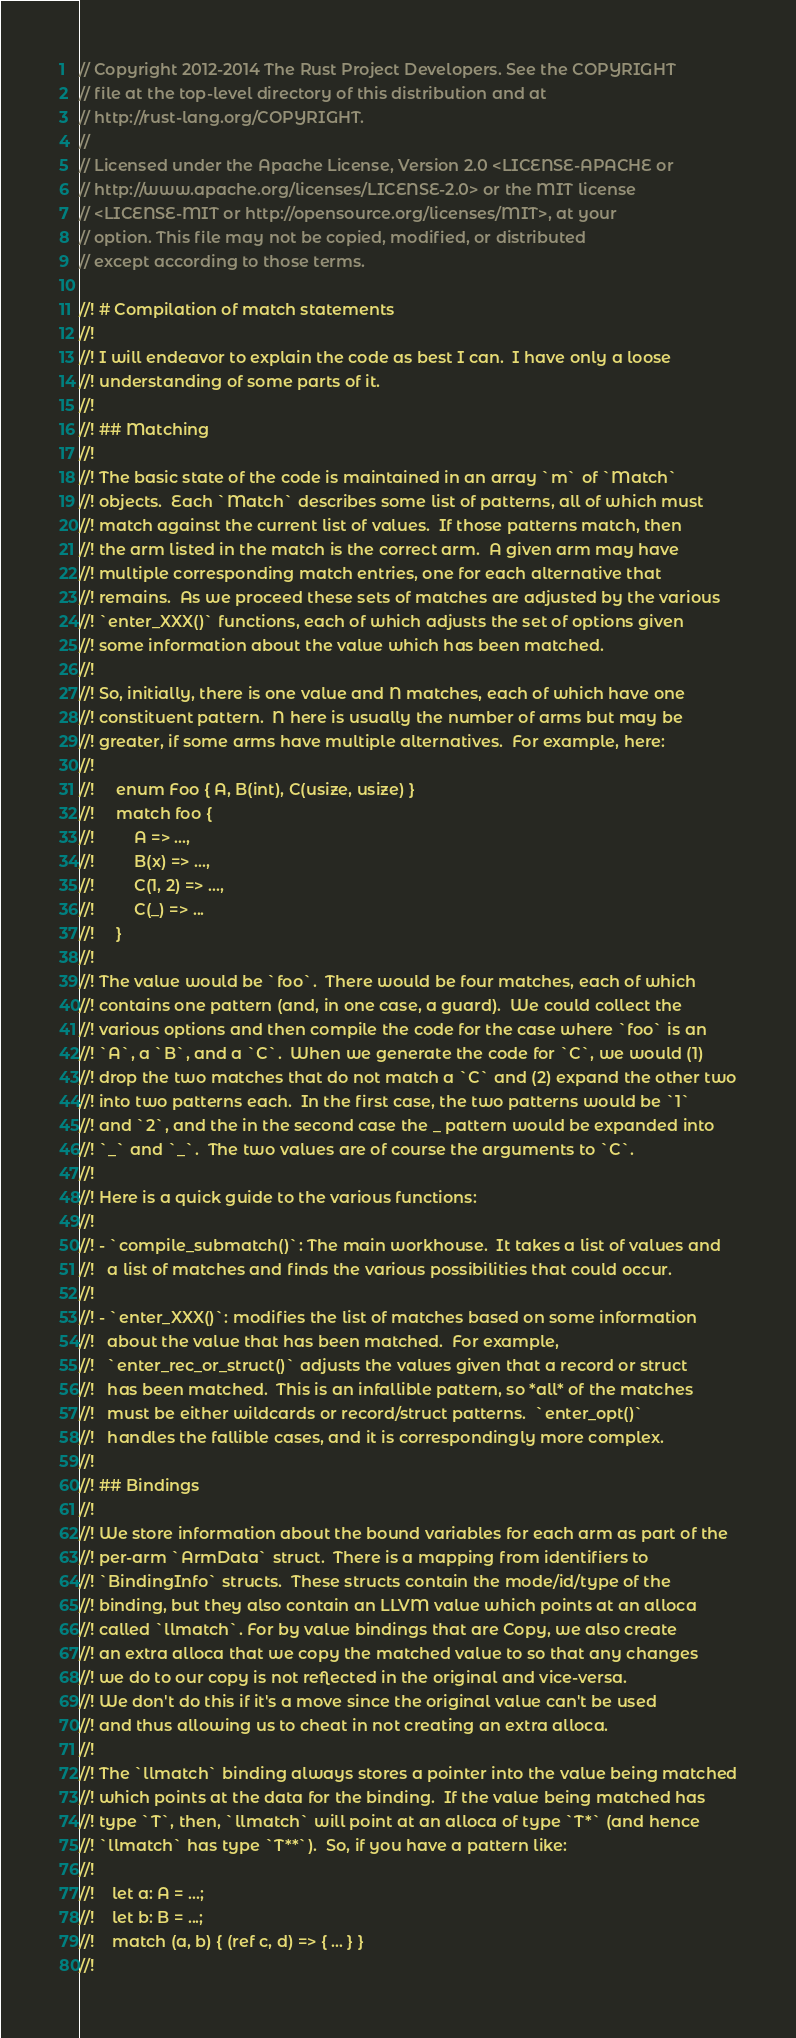Convert code to text. <code><loc_0><loc_0><loc_500><loc_500><_Rust_>// Copyright 2012-2014 The Rust Project Developers. See the COPYRIGHT
// file at the top-level directory of this distribution and at
// http://rust-lang.org/COPYRIGHT.
//
// Licensed under the Apache License, Version 2.0 <LICENSE-APACHE or
// http://www.apache.org/licenses/LICENSE-2.0> or the MIT license
// <LICENSE-MIT or http://opensource.org/licenses/MIT>, at your
// option. This file may not be copied, modified, or distributed
// except according to those terms.

//! # Compilation of match statements
//!
//! I will endeavor to explain the code as best I can.  I have only a loose
//! understanding of some parts of it.
//!
//! ## Matching
//!
//! The basic state of the code is maintained in an array `m` of `Match`
//! objects.  Each `Match` describes some list of patterns, all of which must
//! match against the current list of values.  If those patterns match, then
//! the arm listed in the match is the correct arm.  A given arm may have
//! multiple corresponding match entries, one for each alternative that
//! remains.  As we proceed these sets of matches are adjusted by the various
//! `enter_XXX()` functions, each of which adjusts the set of options given
//! some information about the value which has been matched.
//!
//! So, initially, there is one value and N matches, each of which have one
//! constituent pattern.  N here is usually the number of arms but may be
//! greater, if some arms have multiple alternatives.  For example, here:
//!
//!     enum Foo { A, B(int), C(usize, usize) }
//!     match foo {
//!         A => ...,
//!         B(x) => ...,
//!         C(1, 2) => ...,
//!         C(_) => ...
//!     }
//!
//! The value would be `foo`.  There would be four matches, each of which
//! contains one pattern (and, in one case, a guard).  We could collect the
//! various options and then compile the code for the case where `foo` is an
//! `A`, a `B`, and a `C`.  When we generate the code for `C`, we would (1)
//! drop the two matches that do not match a `C` and (2) expand the other two
//! into two patterns each.  In the first case, the two patterns would be `1`
//! and `2`, and the in the second case the _ pattern would be expanded into
//! `_` and `_`.  The two values are of course the arguments to `C`.
//!
//! Here is a quick guide to the various functions:
//!
//! - `compile_submatch()`: The main workhouse.  It takes a list of values and
//!   a list of matches and finds the various possibilities that could occur.
//!
//! - `enter_XXX()`: modifies the list of matches based on some information
//!   about the value that has been matched.  For example,
//!   `enter_rec_or_struct()` adjusts the values given that a record or struct
//!   has been matched.  This is an infallible pattern, so *all* of the matches
//!   must be either wildcards or record/struct patterns.  `enter_opt()`
//!   handles the fallible cases, and it is correspondingly more complex.
//!
//! ## Bindings
//!
//! We store information about the bound variables for each arm as part of the
//! per-arm `ArmData` struct.  There is a mapping from identifiers to
//! `BindingInfo` structs.  These structs contain the mode/id/type of the
//! binding, but they also contain an LLVM value which points at an alloca
//! called `llmatch`. For by value bindings that are Copy, we also create
//! an extra alloca that we copy the matched value to so that any changes
//! we do to our copy is not reflected in the original and vice-versa.
//! We don't do this if it's a move since the original value can't be used
//! and thus allowing us to cheat in not creating an extra alloca.
//!
//! The `llmatch` binding always stores a pointer into the value being matched
//! which points at the data for the binding.  If the value being matched has
//! type `T`, then, `llmatch` will point at an alloca of type `T*` (and hence
//! `llmatch` has type `T**`).  So, if you have a pattern like:
//!
//!    let a: A = ...;
//!    let b: B = ...;
//!    match (a, b) { (ref c, d) => { ... } }
//!</code> 